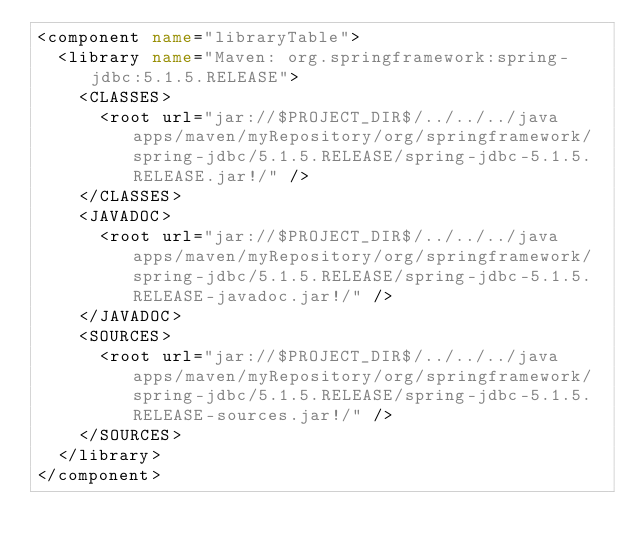<code> <loc_0><loc_0><loc_500><loc_500><_XML_><component name="libraryTable">
  <library name="Maven: org.springframework:spring-jdbc:5.1.5.RELEASE">
    <CLASSES>
      <root url="jar://$PROJECT_DIR$/../../../java apps/maven/myRepository/org/springframework/spring-jdbc/5.1.5.RELEASE/spring-jdbc-5.1.5.RELEASE.jar!/" />
    </CLASSES>
    <JAVADOC>
      <root url="jar://$PROJECT_DIR$/../../../java apps/maven/myRepository/org/springframework/spring-jdbc/5.1.5.RELEASE/spring-jdbc-5.1.5.RELEASE-javadoc.jar!/" />
    </JAVADOC>
    <SOURCES>
      <root url="jar://$PROJECT_DIR$/../../../java apps/maven/myRepository/org/springframework/spring-jdbc/5.1.5.RELEASE/spring-jdbc-5.1.5.RELEASE-sources.jar!/" />
    </SOURCES>
  </library>
</component></code> 